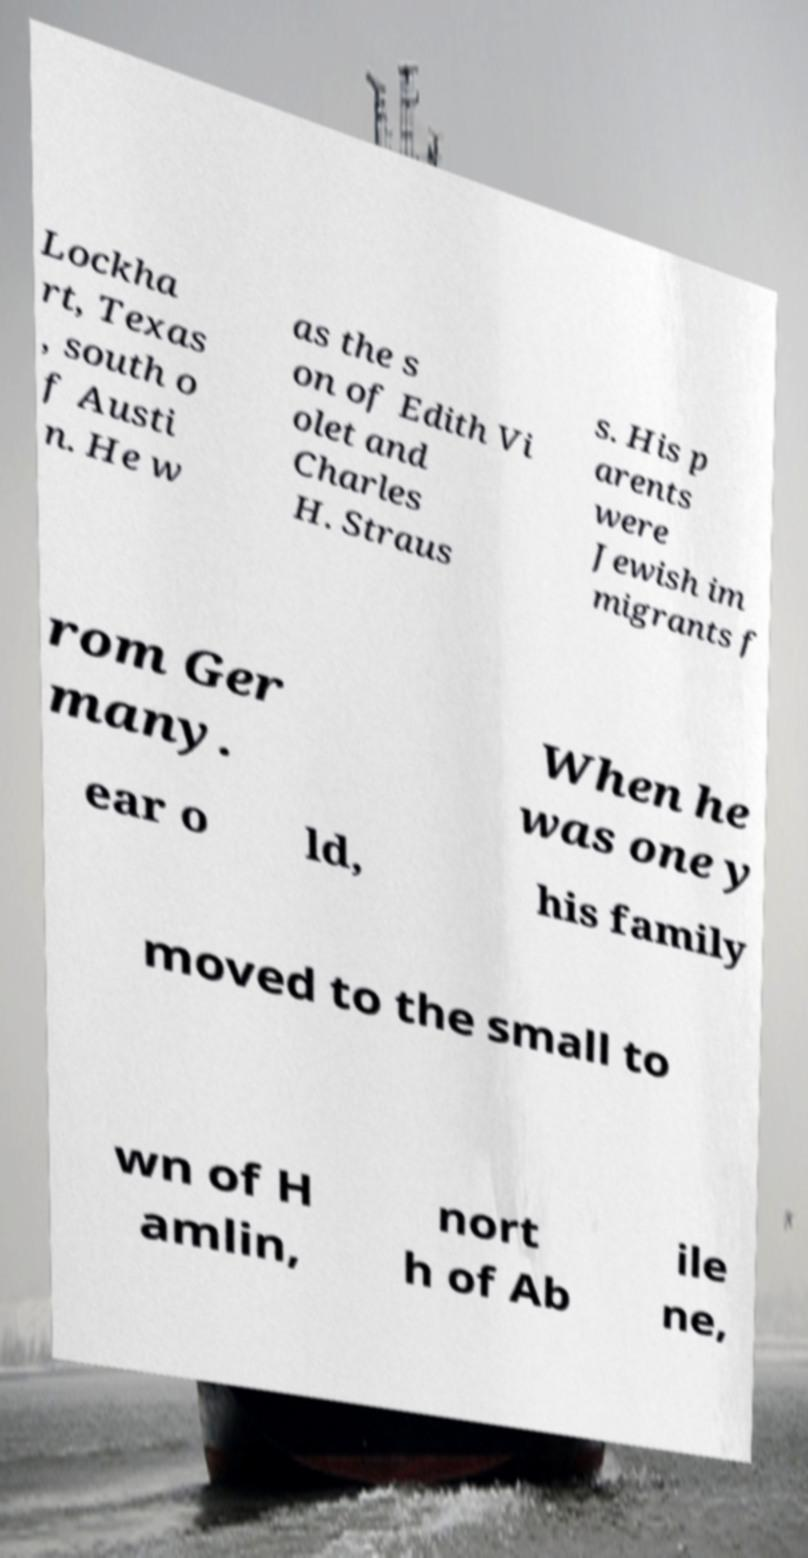Please identify and transcribe the text found in this image. Lockha rt, Texas , south o f Austi n. He w as the s on of Edith Vi olet and Charles H. Straus s. His p arents were Jewish im migrants f rom Ger many. When he was one y ear o ld, his family moved to the small to wn of H amlin, nort h of Ab ile ne, 